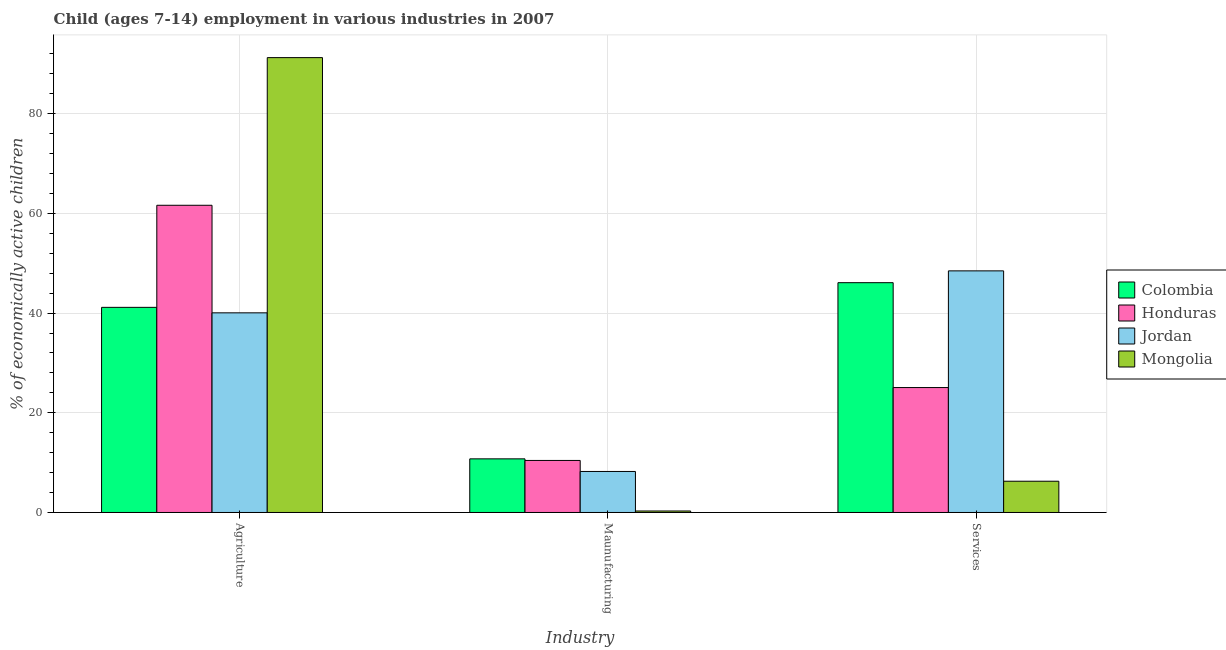How many different coloured bars are there?
Make the answer very short. 4. Are the number of bars on each tick of the X-axis equal?
Offer a very short reply. Yes. How many bars are there on the 1st tick from the left?
Your answer should be compact. 4. What is the label of the 2nd group of bars from the left?
Provide a short and direct response. Maunufacturing. What is the percentage of economically active children in agriculture in Jordan?
Provide a short and direct response. 40.05. Across all countries, what is the maximum percentage of economically active children in manufacturing?
Offer a very short reply. 10.76. Across all countries, what is the minimum percentage of economically active children in services?
Offer a very short reply. 6.27. In which country was the percentage of economically active children in agriculture maximum?
Your answer should be compact. Mongolia. In which country was the percentage of economically active children in agriculture minimum?
Your answer should be very brief. Jordan. What is the total percentage of economically active children in services in the graph?
Provide a succinct answer. 125.9. What is the difference between the percentage of economically active children in agriculture in Jordan and that in Honduras?
Your answer should be very brief. -21.58. What is the difference between the percentage of economically active children in services in Colombia and the percentage of economically active children in agriculture in Mongolia?
Provide a succinct answer. -45.15. What is the average percentage of economically active children in services per country?
Your answer should be compact. 31.47. What is the difference between the percentage of economically active children in manufacturing and percentage of economically active children in agriculture in Colombia?
Provide a short and direct response. -30.39. In how many countries, is the percentage of economically active children in manufacturing greater than 24 %?
Your answer should be compact. 0. What is the ratio of the percentage of economically active children in services in Mongolia to that in Colombia?
Offer a very short reply. 0.14. Is the difference between the percentage of economically active children in manufacturing in Jordan and Mongolia greater than the difference between the percentage of economically active children in services in Jordan and Mongolia?
Your answer should be very brief. No. What is the difference between the highest and the second highest percentage of economically active children in services?
Provide a succinct answer. 2.37. What is the difference between the highest and the lowest percentage of economically active children in manufacturing?
Make the answer very short. 10.46. Is the sum of the percentage of economically active children in agriculture in Mongolia and Colombia greater than the maximum percentage of economically active children in manufacturing across all countries?
Make the answer very short. Yes. What does the 3rd bar from the left in Agriculture represents?
Offer a terse response. Jordan. What does the 1st bar from the right in Maunufacturing represents?
Your answer should be compact. Mongolia. Are all the bars in the graph horizontal?
Make the answer very short. No. What is the difference between two consecutive major ticks on the Y-axis?
Offer a terse response. 20. Are the values on the major ticks of Y-axis written in scientific E-notation?
Your answer should be compact. No. Does the graph contain any zero values?
Your answer should be compact. No. What is the title of the graph?
Make the answer very short. Child (ages 7-14) employment in various industries in 2007. What is the label or title of the X-axis?
Provide a short and direct response. Industry. What is the label or title of the Y-axis?
Your response must be concise. % of economically active children. What is the % of economically active children in Colombia in Agriculture?
Your answer should be very brief. 41.15. What is the % of economically active children of Honduras in Agriculture?
Ensure brevity in your answer.  61.63. What is the % of economically active children of Jordan in Agriculture?
Ensure brevity in your answer.  40.05. What is the % of economically active children of Mongolia in Agriculture?
Offer a very short reply. 91.25. What is the % of economically active children of Colombia in Maunufacturing?
Your answer should be very brief. 10.76. What is the % of economically active children in Honduras in Maunufacturing?
Provide a short and direct response. 10.44. What is the % of economically active children in Jordan in Maunufacturing?
Offer a very short reply. 8.23. What is the % of economically active children of Mongolia in Maunufacturing?
Ensure brevity in your answer.  0.3. What is the % of economically active children in Colombia in Services?
Your response must be concise. 46.1. What is the % of economically active children of Honduras in Services?
Your answer should be very brief. 25.06. What is the % of economically active children in Jordan in Services?
Offer a terse response. 48.47. What is the % of economically active children of Mongolia in Services?
Provide a short and direct response. 6.27. Across all Industry, what is the maximum % of economically active children in Colombia?
Offer a terse response. 46.1. Across all Industry, what is the maximum % of economically active children of Honduras?
Provide a short and direct response. 61.63. Across all Industry, what is the maximum % of economically active children of Jordan?
Your answer should be very brief. 48.47. Across all Industry, what is the maximum % of economically active children of Mongolia?
Your answer should be compact. 91.25. Across all Industry, what is the minimum % of economically active children of Colombia?
Make the answer very short. 10.76. Across all Industry, what is the minimum % of economically active children in Honduras?
Keep it short and to the point. 10.44. Across all Industry, what is the minimum % of economically active children of Jordan?
Provide a short and direct response. 8.23. What is the total % of economically active children of Colombia in the graph?
Your answer should be compact. 98.01. What is the total % of economically active children in Honduras in the graph?
Your answer should be very brief. 97.13. What is the total % of economically active children in Jordan in the graph?
Provide a short and direct response. 96.75. What is the total % of economically active children of Mongolia in the graph?
Provide a short and direct response. 97.82. What is the difference between the % of economically active children of Colombia in Agriculture and that in Maunufacturing?
Your answer should be very brief. 30.39. What is the difference between the % of economically active children of Honduras in Agriculture and that in Maunufacturing?
Ensure brevity in your answer.  51.19. What is the difference between the % of economically active children of Jordan in Agriculture and that in Maunufacturing?
Make the answer very short. 31.82. What is the difference between the % of economically active children in Mongolia in Agriculture and that in Maunufacturing?
Offer a very short reply. 90.95. What is the difference between the % of economically active children in Colombia in Agriculture and that in Services?
Offer a terse response. -4.95. What is the difference between the % of economically active children in Honduras in Agriculture and that in Services?
Your response must be concise. 36.57. What is the difference between the % of economically active children of Jordan in Agriculture and that in Services?
Your answer should be compact. -8.42. What is the difference between the % of economically active children of Mongolia in Agriculture and that in Services?
Make the answer very short. 84.98. What is the difference between the % of economically active children of Colombia in Maunufacturing and that in Services?
Your response must be concise. -35.34. What is the difference between the % of economically active children in Honduras in Maunufacturing and that in Services?
Your response must be concise. -14.62. What is the difference between the % of economically active children of Jordan in Maunufacturing and that in Services?
Give a very brief answer. -40.24. What is the difference between the % of economically active children of Mongolia in Maunufacturing and that in Services?
Offer a terse response. -5.97. What is the difference between the % of economically active children of Colombia in Agriculture and the % of economically active children of Honduras in Maunufacturing?
Provide a succinct answer. 30.71. What is the difference between the % of economically active children of Colombia in Agriculture and the % of economically active children of Jordan in Maunufacturing?
Provide a succinct answer. 32.92. What is the difference between the % of economically active children in Colombia in Agriculture and the % of economically active children in Mongolia in Maunufacturing?
Make the answer very short. 40.85. What is the difference between the % of economically active children of Honduras in Agriculture and the % of economically active children of Jordan in Maunufacturing?
Your answer should be very brief. 53.4. What is the difference between the % of economically active children in Honduras in Agriculture and the % of economically active children in Mongolia in Maunufacturing?
Your answer should be compact. 61.33. What is the difference between the % of economically active children of Jordan in Agriculture and the % of economically active children of Mongolia in Maunufacturing?
Keep it short and to the point. 39.75. What is the difference between the % of economically active children in Colombia in Agriculture and the % of economically active children in Honduras in Services?
Give a very brief answer. 16.09. What is the difference between the % of economically active children of Colombia in Agriculture and the % of economically active children of Jordan in Services?
Ensure brevity in your answer.  -7.32. What is the difference between the % of economically active children of Colombia in Agriculture and the % of economically active children of Mongolia in Services?
Your answer should be very brief. 34.88. What is the difference between the % of economically active children of Honduras in Agriculture and the % of economically active children of Jordan in Services?
Offer a very short reply. 13.16. What is the difference between the % of economically active children in Honduras in Agriculture and the % of economically active children in Mongolia in Services?
Offer a very short reply. 55.36. What is the difference between the % of economically active children of Jordan in Agriculture and the % of economically active children of Mongolia in Services?
Offer a terse response. 33.78. What is the difference between the % of economically active children of Colombia in Maunufacturing and the % of economically active children of Honduras in Services?
Offer a terse response. -14.3. What is the difference between the % of economically active children in Colombia in Maunufacturing and the % of economically active children in Jordan in Services?
Ensure brevity in your answer.  -37.71. What is the difference between the % of economically active children of Colombia in Maunufacturing and the % of economically active children of Mongolia in Services?
Your answer should be compact. 4.49. What is the difference between the % of economically active children of Honduras in Maunufacturing and the % of economically active children of Jordan in Services?
Offer a very short reply. -38.03. What is the difference between the % of economically active children of Honduras in Maunufacturing and the % of economically active children of Mongolia in Services?
Your response must be concise. 4.17. What is the difference between the % of economically active children in Jordan in Maunufacturing and the % of economically active children in Mongolia in Services?
Keep it short and to the point. 1.96. What is the average % of economically active children in Colombia per Industry?
Offer a terse response. 32.67. What is the average % of economically active children in Honduras per Industry?
Ensure brevity in your answer.  32.38. What is the average % of economically active children of Jordan per Industry?
Offer a very short reply. 32.25. What is the average % of economically active children in Mongolia per Industry?
Your answer should be compact. 32.61. What is the difference between the % of economically active children in Colombia and % of economically active children in Honduras in Agriculture?
Make the answer very short. -20.48. What is the difference between the % of economically active children of Colombia and % of economically active children of Jordan in Agriculture?
Make the answer very short. 1.1. What is the difference between the % of economically active children in Colombia and % of economically active children in Mongolia in Agriculture?
Give a very brief answer. -50.1. What is the difference between the % of economically active children of Honduras and % of economically active children of Jordan in Agriculture?
Your answer should be compact. 21.58. What is the difference between the % of economically active children in Honduras and % of economically active children in Mongolia in Agriculture?
Offer a terse response. -29.62. What is the difference between the % of economically active children of Jordan and % of economically active children of Mongolia in Agriculture?
Give a very brief answer. -51.2. What is the difference between the % of economically active children in Colombia and % of economically active children in Honduras in Maunufacturing?
Make the answer very short. 0.32. What is the difference between the % of economically active children of Colombia and % of economically active children of Jordan in Maunufacturing?
Provide a succinct answer. 2.53. What is the difference between the % of economically active children in Colombia and % of economically active children in Mongolia in Maunufacturing?
Offer a terse response. 10.46. What is the difference between the % of economically active children of Honduras and % of economically active children of Jordan in Maunufacturing?
Make the answer very short. 2.21. What is the difference between the % of economically active children in Honduras and % of economically active children in Mongolia in Maunufacturing?
Offer a terse response. 10.14. What is the difference between the % of economically active children in Jordan and % of economically active children in Mongolia in Maunufacturing?
Your answer should be very brief. 7.93. What is the difference between the % of economically active children in Colombia and % of economically active children in Honduras in Services?
Ensure brevity in your answer.  21.04. What is the difference between the % of economically active children of Colombia and % of economically active children of Jordan in Services?
Provide a short and direct response. -2.37. What is the difference between the % of economically active children of Colombia and % of economically active children of Mongolia in Services?
Offer a terse response. 39.83. What is the difference between the % of economically active children of Honduras and % of economically active children of Jordan in Services?
Your response must be concise. -23.41. What is the difference between the % of economically active children of Honduras and % of economically active children of Mongolia in Services?
Your answer should be compact. 18.79. What is the difference between the % of economically active children in Jordan and % of economically active children in Mongolia in Services?
Your answer should be compact. 42.2. What is the ratio of the % of economically active children in Colombia in Agriculture to that in Maunufacturing?
Offer a terse response. 3.82. What is the ratio of the % of economically active children of Honduras in Agriculture to that in Maunufacturing?
Give a very brief answer. 5.9. What is the ratio of the % of economically active children of Jordan in Agriculture to that in Maunufacturing?
Make the answer very short. 4.87. What is the ratio of the % of economically active children of Mongolia in Agriculture to that in Maunufacturing?
Provide a succinct answer. 304.17. What is the ratio of the % of economically active children of Colombia in Agriculture to that in Services?
Provide a short and direct response. 0.89. What is the ratio of the % of economically active children of Honduras in Agriculture to that in Services?
Your answer should be very brief. 2.46. What is the ratio of the % of economically active children in Jordan in Agriculture to that in Services?
Ensure brevity in your answer.  0.83. What is the ratio of the % of economically active children of Mongolia in Agriculture to that in Services?
Your response must be concise. 14.55. What is the ratio of the % of economically active children of Colombia in Maunufacturing to that in Services?
Provide a succinct answer. 0.23. What is the ratio of the % of economically active children of Honduras in Maunufacturing to that in Services?
Your response must be concise. 0.42. What is the ratio of the % of economically active children in Jordan in Maunufacturing to that in Services?
Ensure brevity in your answer.  0.17. What is the ratio of the % of economically active children of Mongolia in Maunufacturing to that in Services?
Your answer should be compact. 0.05. What is the difference between the highest and the second highest % of economically active children of Colombia?
Make the answer very short. 4.95. What is the difference between the highest and the second highest % of economically active children of Honduras?
Your response must be concise. 36.57. What is the difference between the highest and the second highest % of economically active children of Jordan?
Offer a terse response. 8.42. What is the difference between the highest and the second highest % of economically active children of Mongolia?
Your answer should be compact. 84.98. What is the difference between the highest and the lowest % of economically active children in Colombia?
Offer a very short reply. 35.34. What is the difference between the highest and the lowest % of economically active children in Honduras?
Offer a very short reply. 51.19. What is the difference between the highest and the lowest % of economically active children in Jordan?
Make the answer very short. 40.24. What is the difference between the highest and the lowest % of economically active children in Mongolia?
Keep it short and to the point. 90.95. 